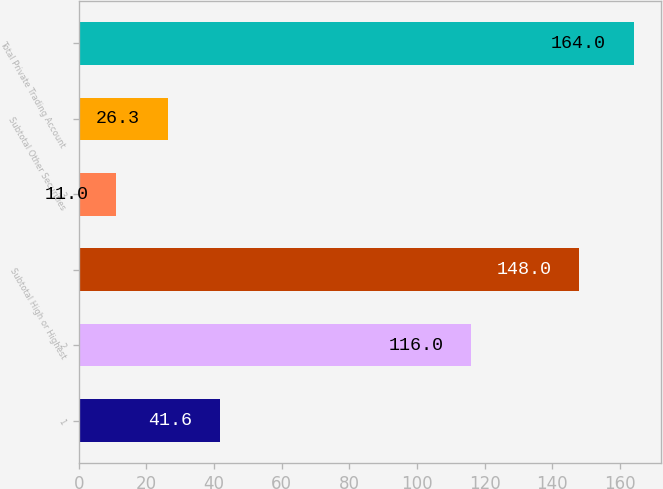<chart> <loc_0><loc_0><loc_500><loc_500><bar_chart><fcel>1<fcel>2<fcel>Subtotal High or Highest<fcel>3<fcel>Subtotal Other Securities<fcel>Total Private Trading Account<nl><fcel>41.6<fcel>116<fcel>148<fcel>11<fcel>26.3<fcel>164<nl></chart> 